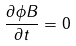Convert formula to latex. <formula><loc_0><loc_0><loc_500><loc_500>\frac { \partial \phi B } { \partial t } = 0</formula> 